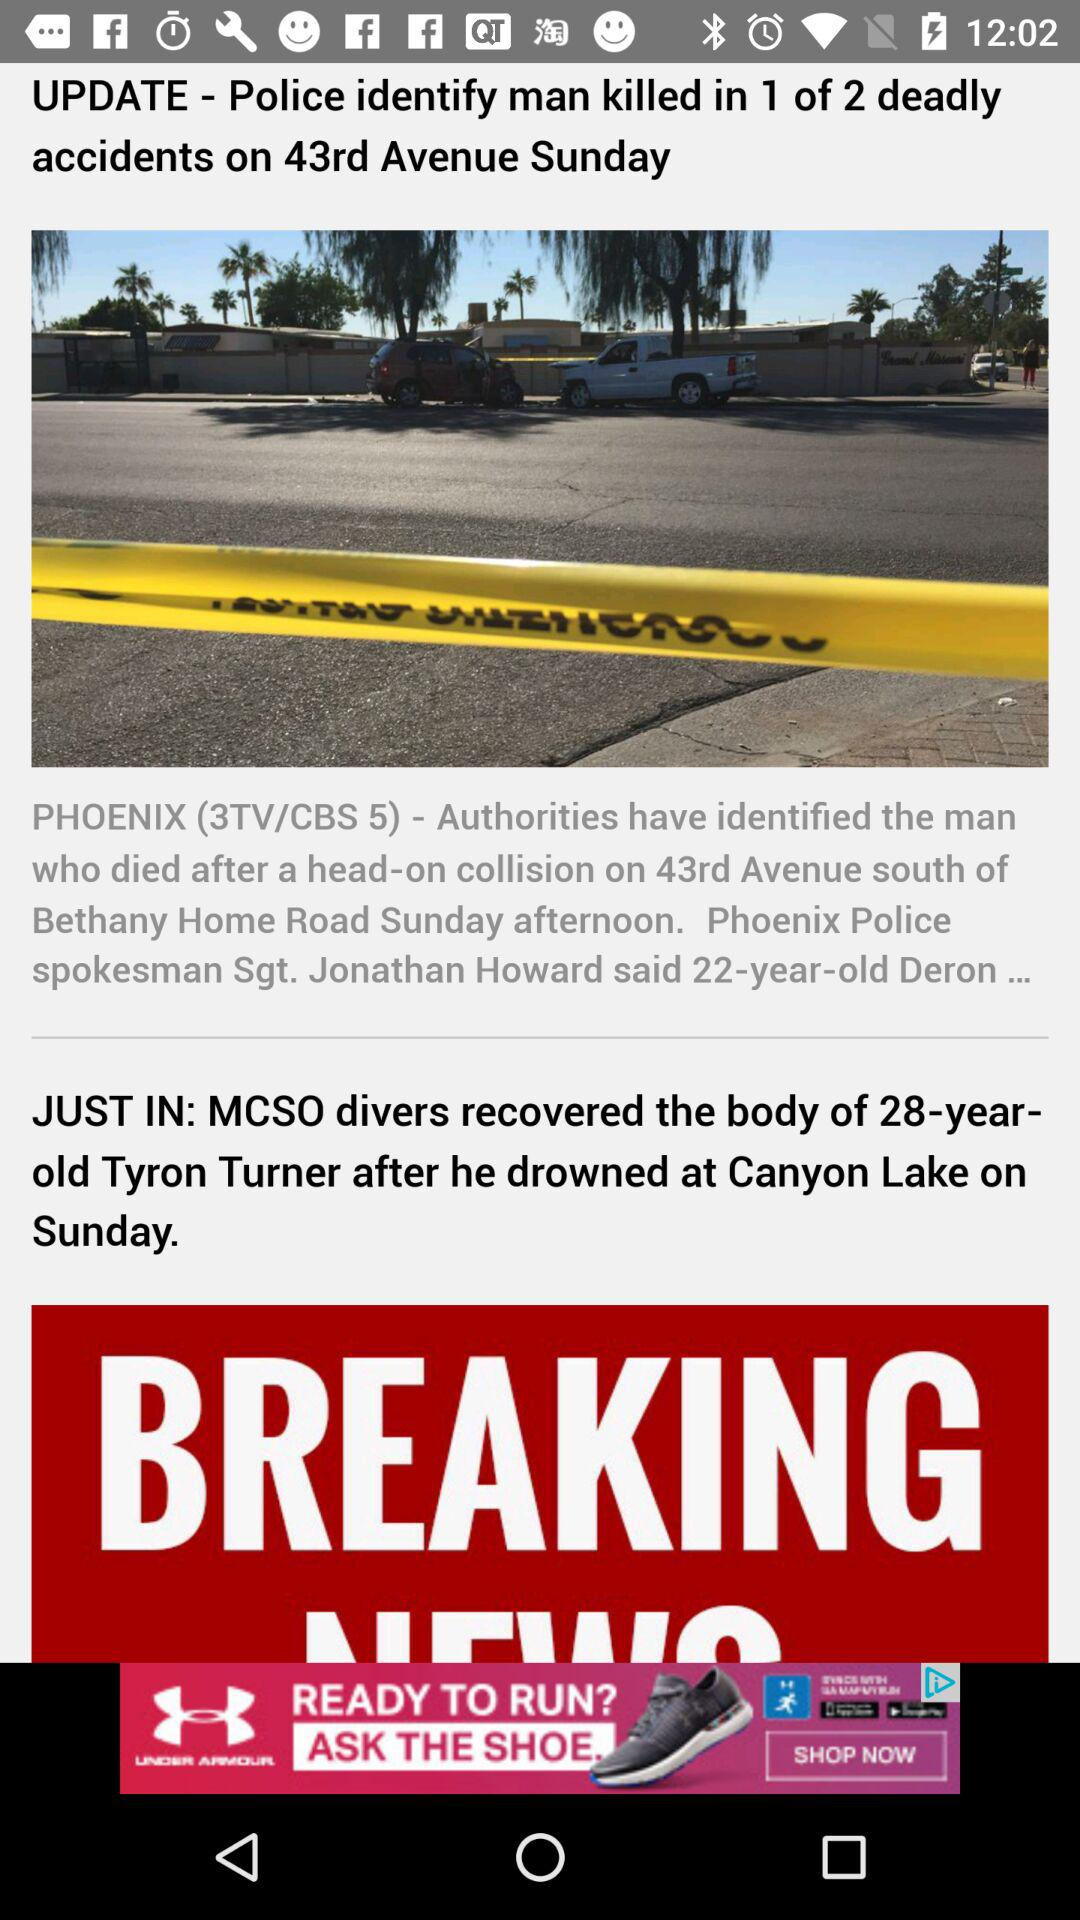What is the age of the man who was killed in 1 of 2 deadly accidents? The age is 22 years old. 